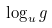Convert formula to latex. <formula><loc_0><loc_0><loc_500><loc_500>\log _ { u } g \,</formula> 